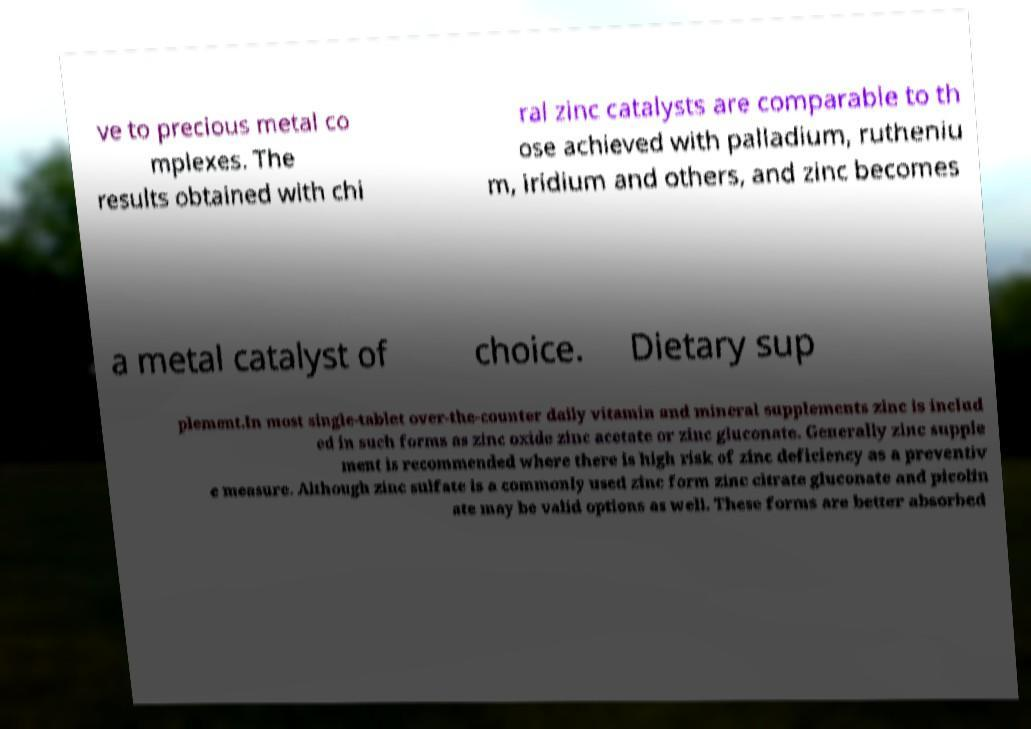Can you read and provide the text displayed in the image?This photo seems to have some interesting text. Can you extract and type it out for me? ve to precious metal co mplexes. The results obtained with chi ral zinc catalysts are comparable to th ose achieved with palladium, rutheniu m, iridium and others, and zinc becomes a metal catalyst of choice. Dietary sup plement.In most single-tablet over-the-counter daily vitamin and mineral supplements zinc is includ ed in such forms as zinc oxide zinc acetate or zinc gluconate. Generally zinc supple ment is recommended where there is high risk of zinc deficiency as a preventiv e measure. Although zinc sulfate is a commonly used zinc form zinc citrate gluconate and picolin ate may be valid options as well. These forms are better absorbed 